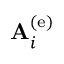<formula> <loc_0><loc_0><loc_500><loc_500>{ A } _ { i } ^ { \left ( e \right ) }</formula> 